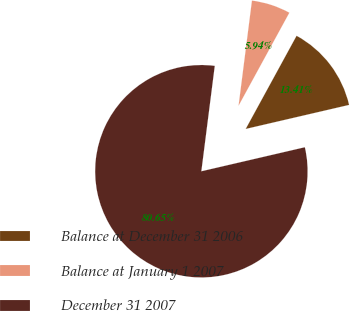Convert chart to OTSL. <chart><loc_0><loc_0><loc_500><loc_500><pie_chart><fcel>Balance at December 31 2006<fcel>Balance at January 1 2007<fcel>December 31 2007<nl><fcel>13.41%<fcel>5.94%<fcel>80.65%<nl></chart> 